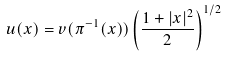Convert formula to latex. <formula><loc_0><loc_0><loc_500><loc_500>u ( x ) = v ( \pi ^ { - 1 } ( x ) ) \left ( \frac { 1 + | x | ^ { 2 } } { 2 } \right ) ^ { 1 / 2 }</formula> 